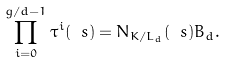<formula> <loc_0><loc_0><loc_500><loc_500>\prod _ { i = 0 } ^ { g / d - 1 } \tau ^ { i } ( \ s ) = N _ { K / L _ { d } } ( \ s ) B _ { d } .</formula> 